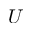<formula> <loc_0><loc_0><loc_500><loc_500>U</formula> 